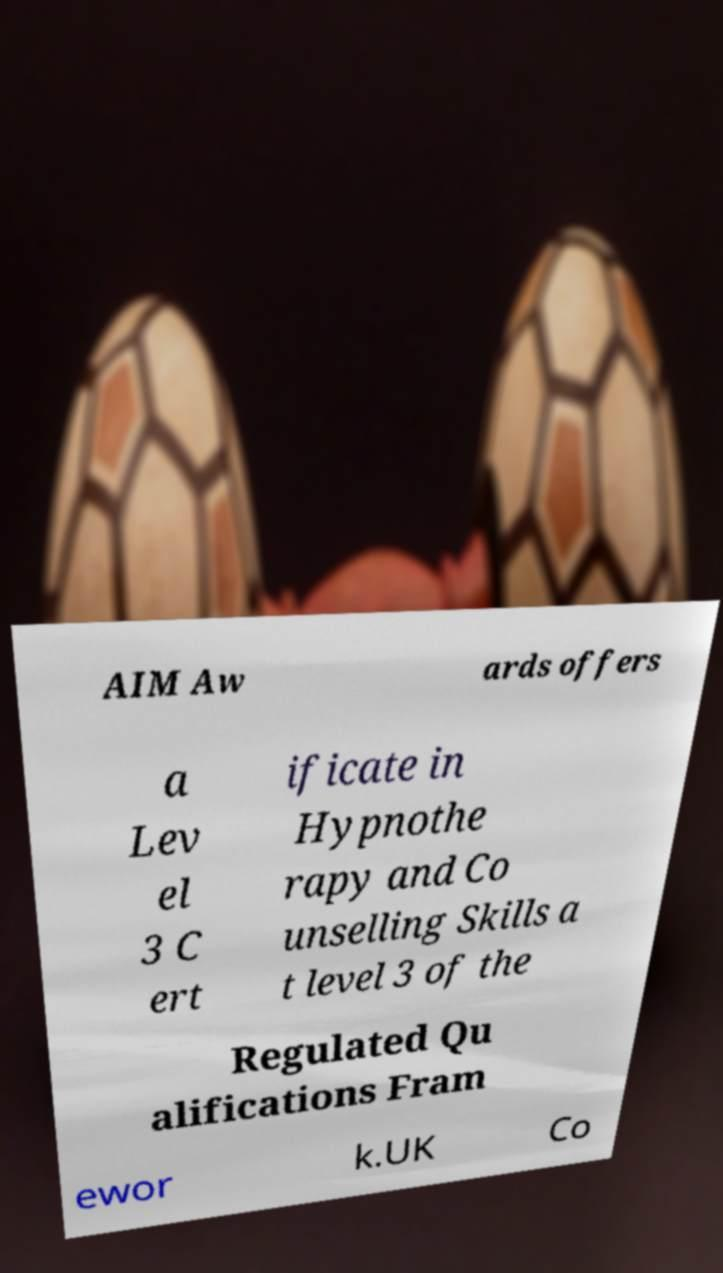There's text embedded in this image that I need extracted. Can you transcribe it verbatim? AIM Aw ards offers a Lev el 3 C ert ificate in Hypnothe rapy and Co unselling Skills a t level 3 of the Regulated Qu alifications Fram ewor k.UK Co 